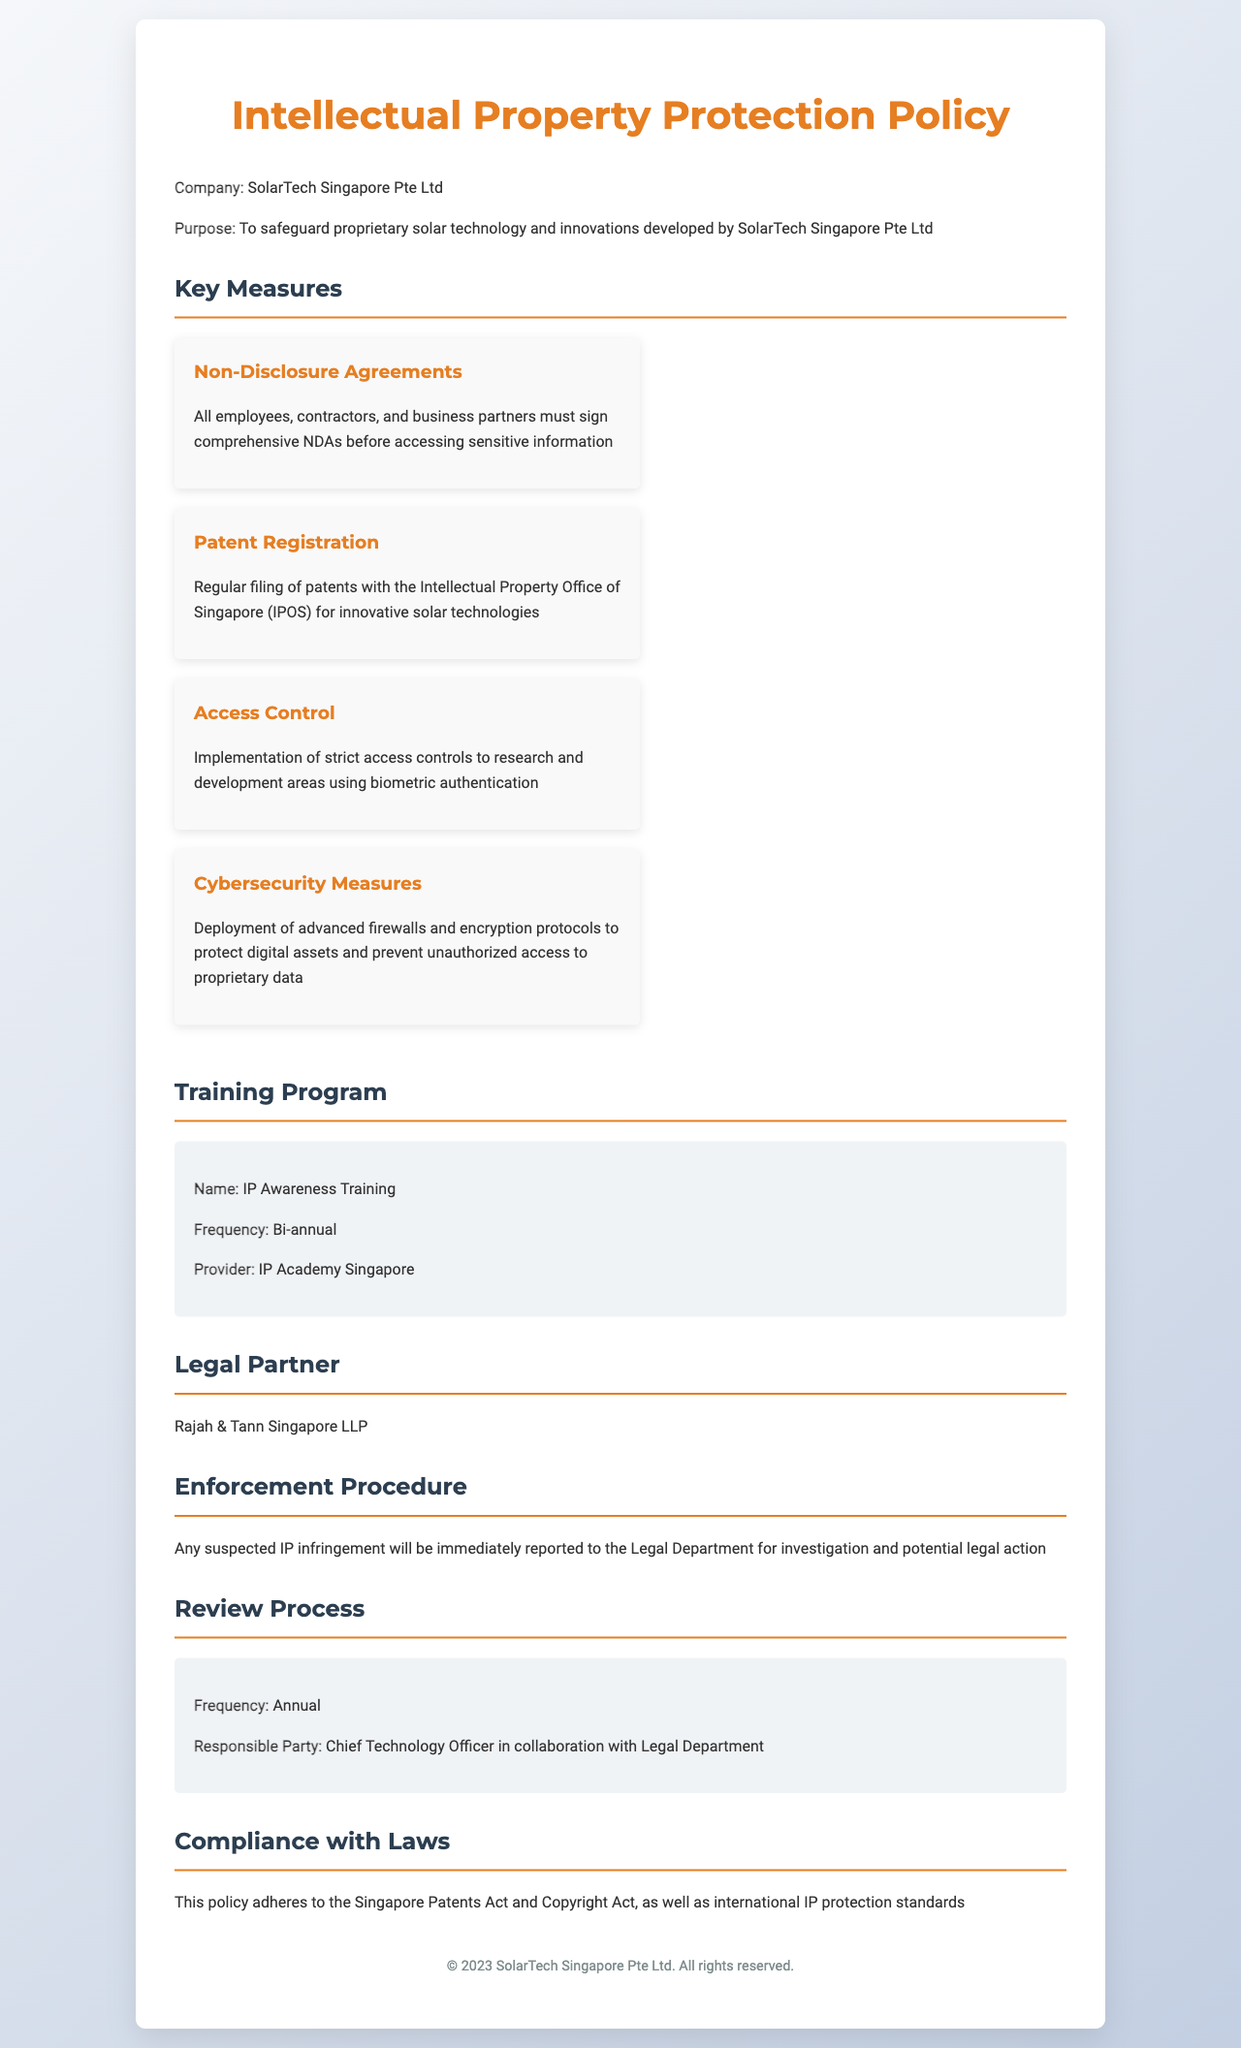what is the purpose of the policy? The purpose is to safeguard proprietary solar technology and innovations developed by SolarTech Singapore Pte Ltd.
Answer: to safeguard proprietary solar technology and innovations who must sign NDAs? The document states that all employees, contractors, and business partners must sign NDAs.
Answer: all employees, contractors, and business partners how often is the IP Awareness Training conducted? The document mentions the frequency of the training program as bi-annual.
Answer: Bi-annual which law firm is the legal partner? The document identifies Rajah & Tann Singapore LLP as the legal partner.
Answer: Rajah & Tann Singapore LLP what is the frequency of the review process? The document specifies that the review process occurs annually.
Answer: Annual what measures are in place to protect digital assets? The policy details that advanced firewalls and encryption protocols are deployed for protection.
Answer: advanced firewalls and encryption protocols who is responsible for the review process? It is stated that the Chief Technology Officer collaborates with the Legal Department for the review.
Answer: Chief Technology Officer in collaboration with Legal Department what type of agreements must be signed before accessing sensitive information? The document specifies that comprehensive NDAs must be signed.
Answer: comprehensive NDAs 